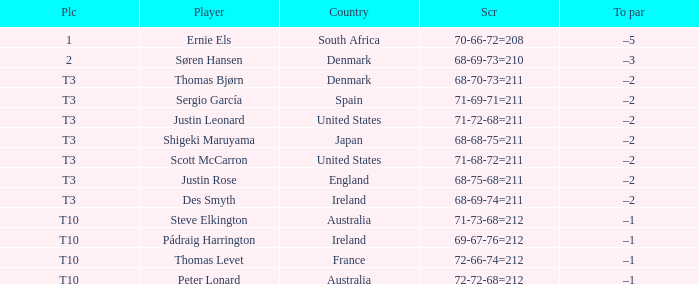What player scored 71-69-71=211? Sergio García. 